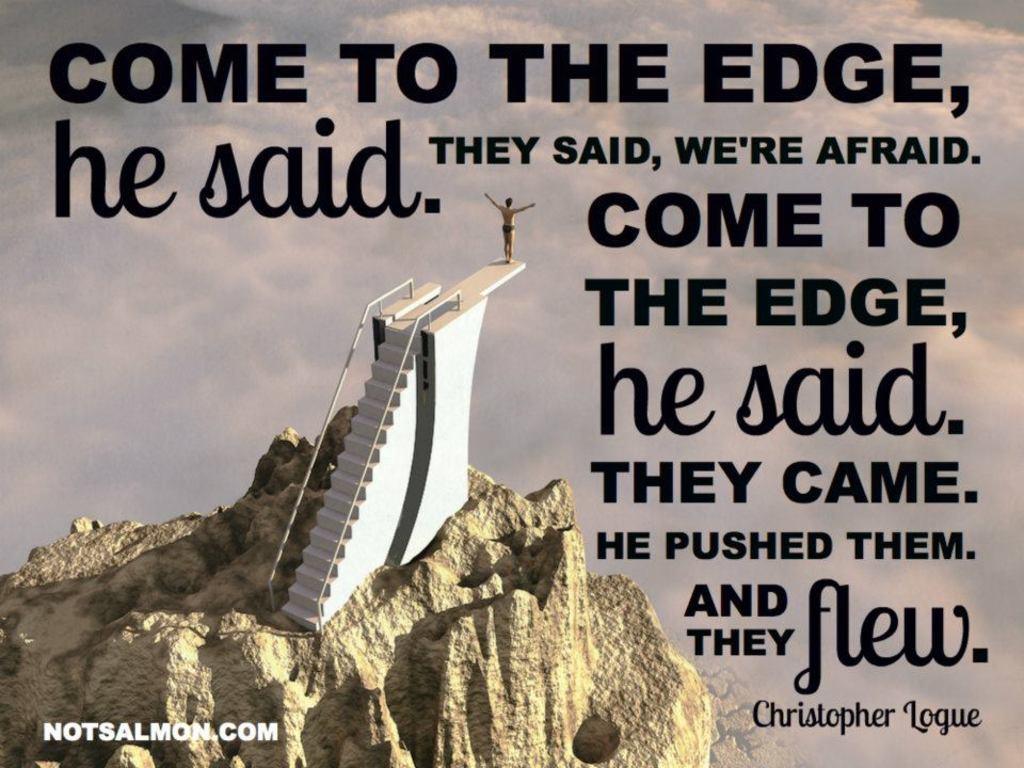<image>
Create a compact narrative representing the image presented. The poster features a quote from Chistopher Logue. 